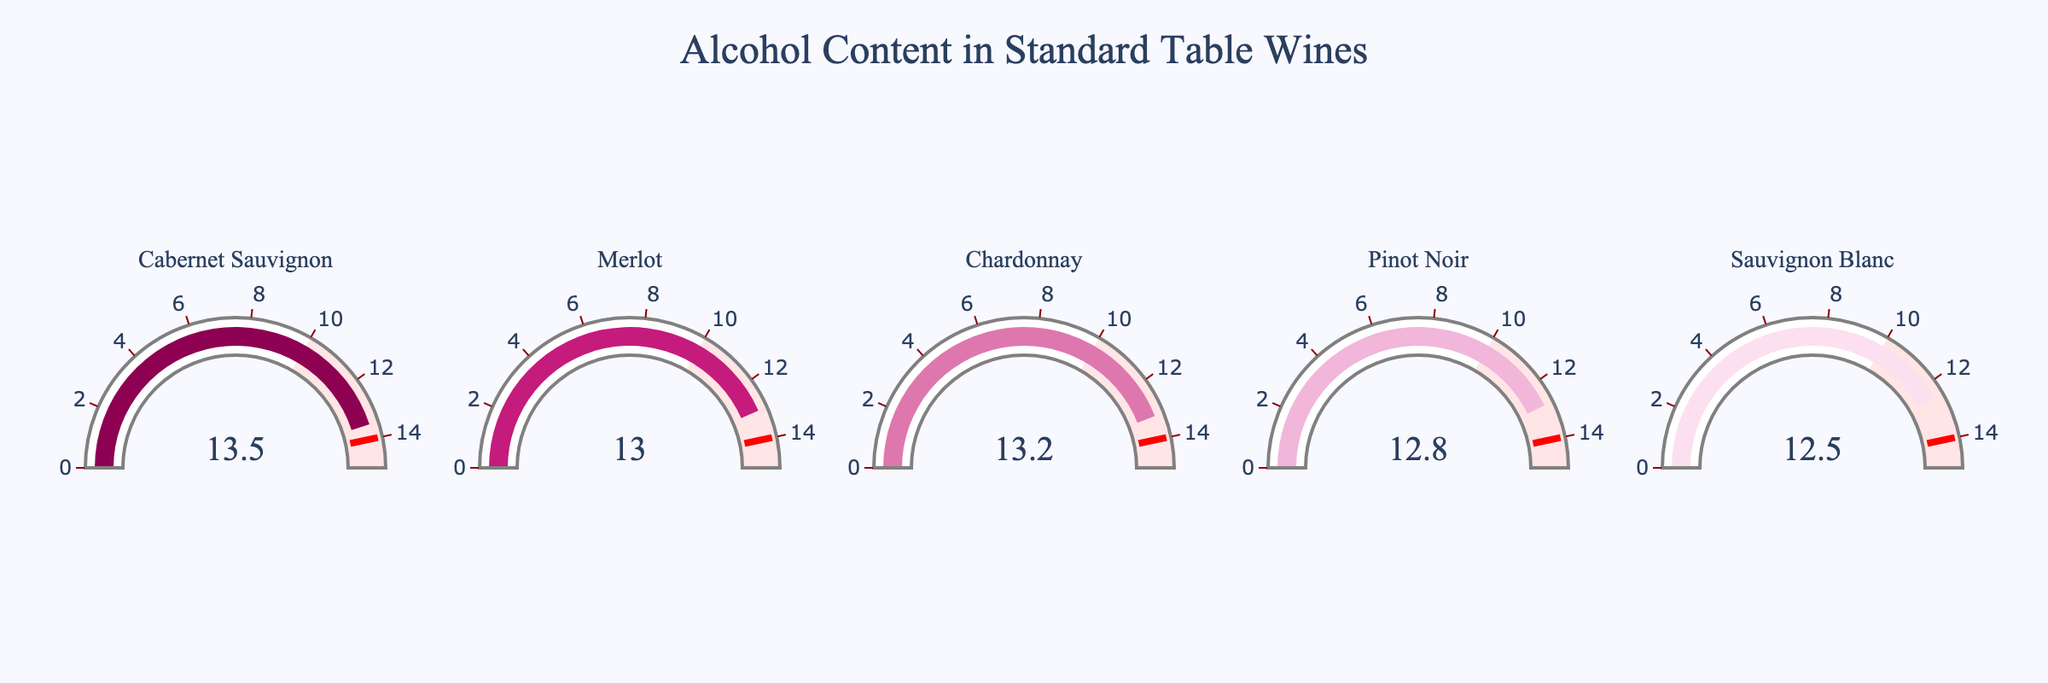What's the alcohol content of Cabernet Sauvignon? The figure clearly shows gauges representing different wines, and the gauge for Cabernet Sauvignon indicates an alcohol content of 13.5%.
Answer: 13.5% Which wine has the lowest alcohol content among the listed wines? By examining all the gauges, Sauvignon Blanc shows the lowest alcohol content at 12.5%.
Answer: Sauvignon Blanc What is the average alcohol content of the five wines presented? Sum up the alcohol content percentages (13.5 + 13.0 + 13.2 + 12.8 + 12.5) to get 65, then divide by the number of wines, which is 5. The average is 65/5.
Answer: 13.0% How much higher is the alcohol content of Cabernet Sauvignon compared to Pinot Noir? The gauge shows Cabernet Sauvignon has 13.5% and Pinot Noir has 12.8%. Subtract Pinot Noir's value from Cabernet Sauvignon's (13.5 - 12.8).
Answer: 0.7% Which wine has an alcohol content equal to or greater than 13.0%? By inspecting the gauges, Cabernet Sauvignon, Merlot, and Chardonnay all have values equal to or above 13.0%.
Answer: Cabernet Sauvignon, Merlot, Chardonnay If you combine the alcohol content of Chardonnay and Sauvignon Blanc, what will be the total percentage? Add the alcohol content of Chardonnay (13.2%) and Sauvignon Blanc (12.5%). (13.2 + 12.5)
Answer: 25.7% Which wine is closest to the threshold limit of 14% shown in the gauge? By analyzing the gauges, Cabernet Sauvignon is at 13.5%, which is the closest value to the 14% threshold.
Answer: Cabernet Sauvignon How many wines have an alcohol content less than 13%? Inspecting the gauges shows Pinot Noir (12.8%) and Sauvignon Blanc (12.5%) have alcohol content less than 13%.
Answer: 2 Compare the alcohol content of Merlot and Chardonnay; which one has a higher value? According to the gauges, Merlot has an alcohol content of 13.0%, while Chardonnay has 13.2%. Chardonnay has a higher value.
Answer: Chardonnay What is the combined alcohol content of all wines? Sum the alcohol content of all wines: 13.5 + 13.0 + 13.2 + 12.8 + 12.5 = 65.
Answer: 65% 